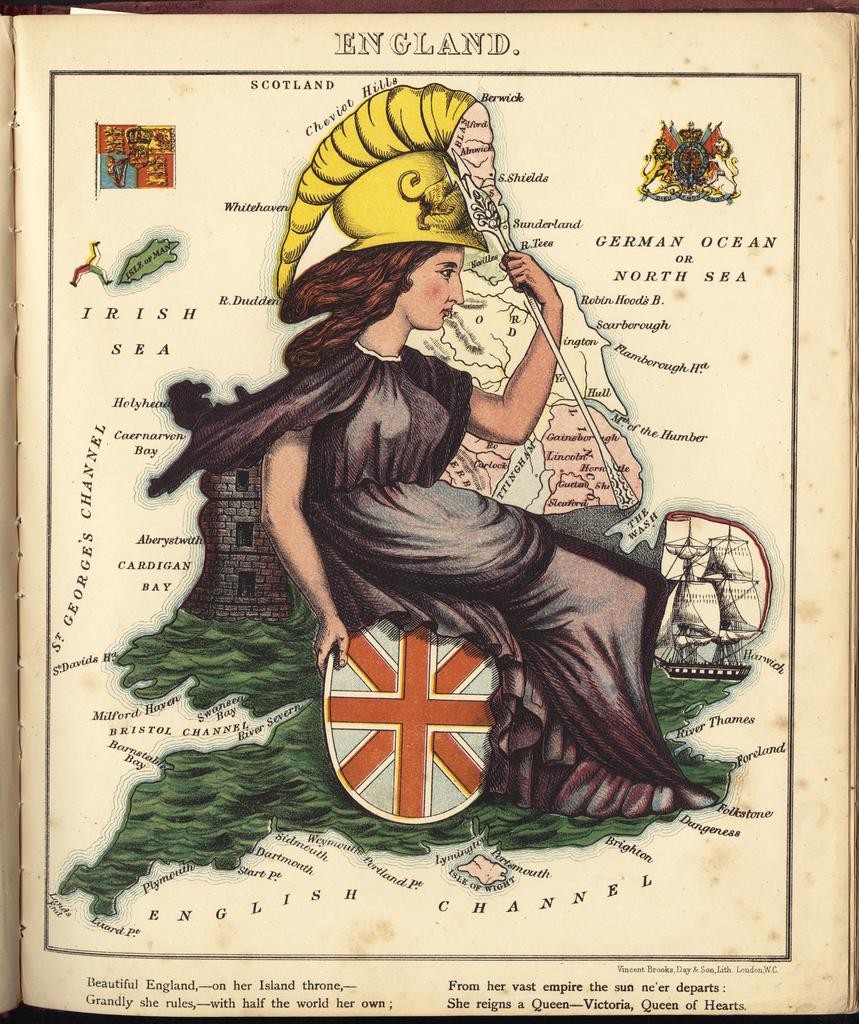What is the main object in the image? There is a book in the image. What else can be seen in the image besides the book? There is a picture of a lady printed on paper in the image. Is there any text present in the image? Yes, there is text in the image. How many eggs are visible in the image? There are no eggs present in the image. Is there a hook attached to the lady's picture in the image? There is no hook visible in the image. 